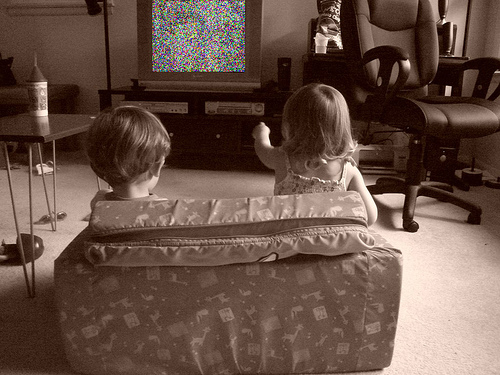<image>What are the kids watching? It is unknown what the kids are watching. It could be a fuzzy screen or static on the TV. What are the kids watching? I don't know what the kids are watching. It can be a TV show or static on the screen. 